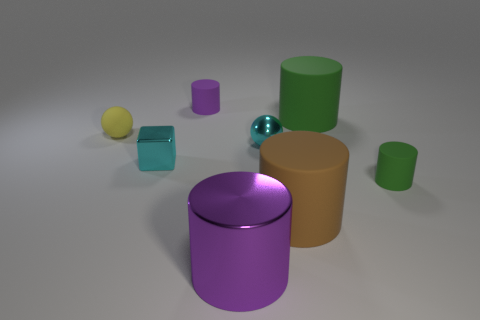There is a cube that is the same size as the yellow ball; what is its material?
Make the answer very short. Metal. There is a purple object behind the brown thing; how big is it?
Give a very brief answer. Small. What is the size of the cube?
Make the answer very short. Small. Does the shiny sphere have the same size as the purple object in front of the shiny sphere?
Give a very brief answer. No. What is the color of the tiny shiny thing on the left side of the purple metallic object left of the brown object?
Provide a succinct answer. Cyan. Are there an equal number of tiny cyan metallic cubes that are in front of the tiny green thing and yellow rubber things behind the small yellow thing?
Your answer should be compact. Yes. Do the large thing behind the brown thing and the tiny yellow ball have the same material?
Ensure brevity in your answer.  Yes. The object that is both on the left side of the shiny cylinder and right of the cyan shiny cube is what color?
Provide a succinct answer. Purple. There is a tiny cyan object on the right side of the big shiny cylinder; how many small spheres are behind it?
Make the answer very short. 1. There is another small object that is the same shape as the tiny yellow object; what is its material?
Keep it short and to the point. Metal. 